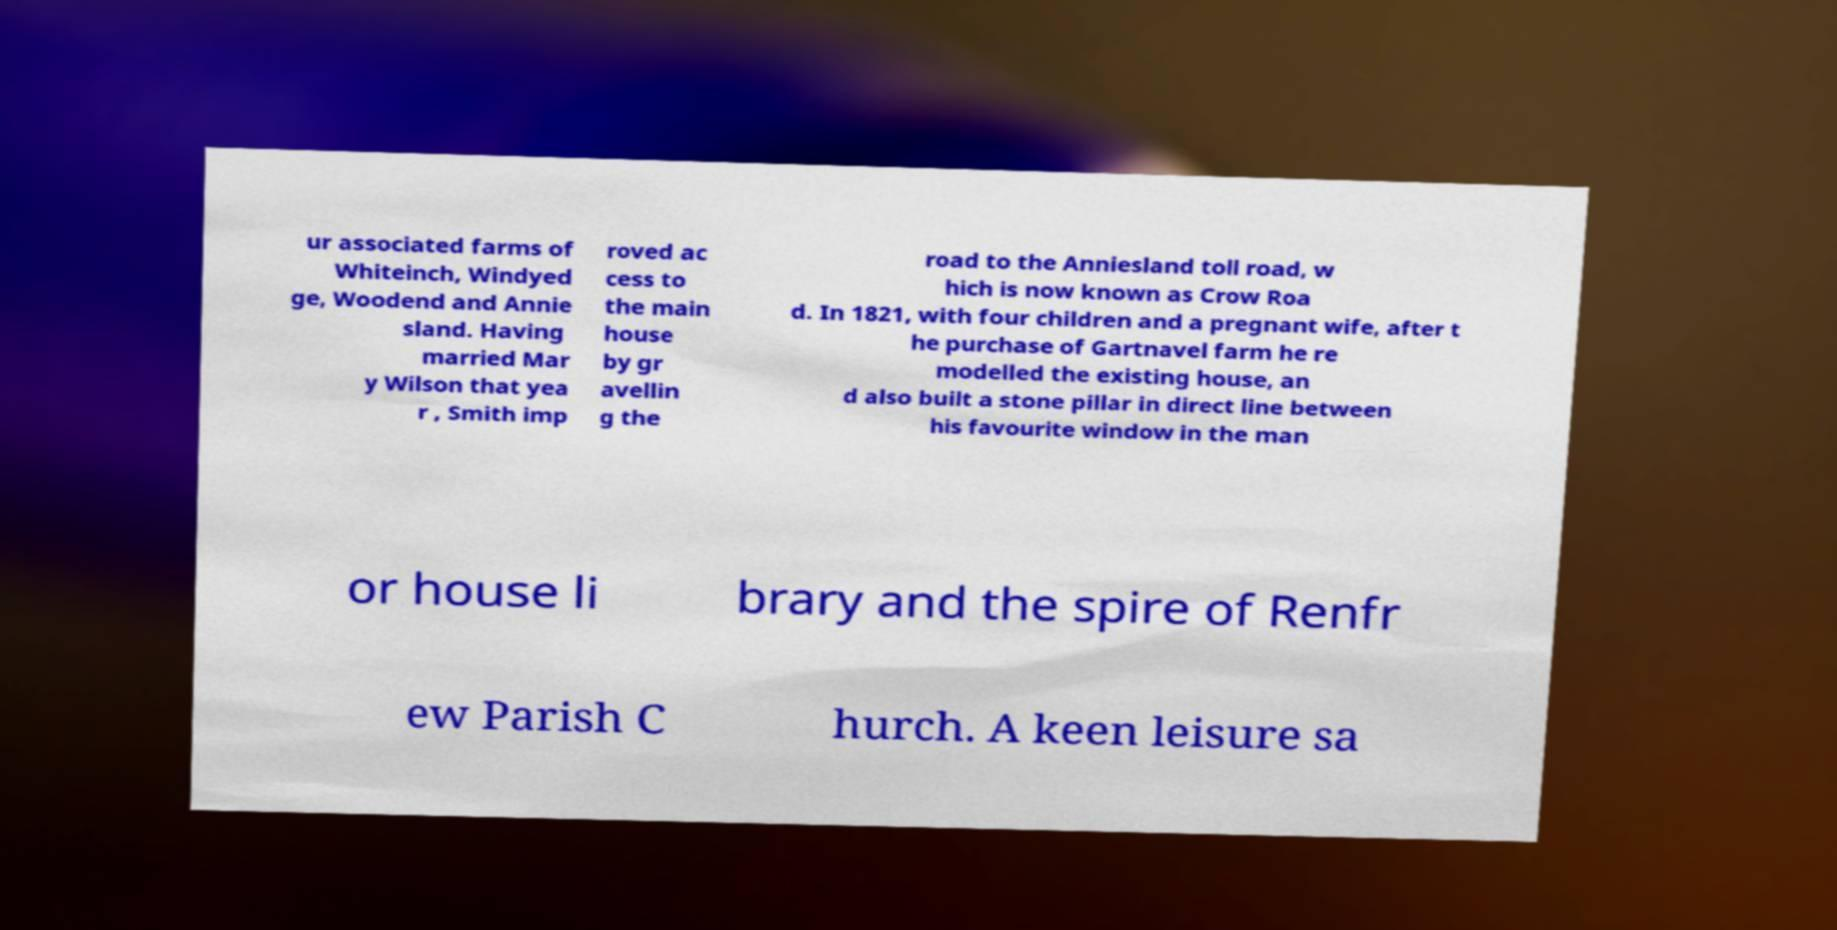What messages or text are displayed in this image? I need them in a readable, typed format. ur associated farms of Whiteinch, Windyed ge, Woodend and Annie sland. Having married Mar y Wilson that yea r , Smith imp roved ac cess to the main house by gr avellin g the road to the Anniesland toll road, w hich is now known as Crow Roa d. In 1821, with four children and a pregnant wife, after t he purchase of Gartnavel farm he re modelled the existing house, an d also built a stone pillar in direct line between his favourite window in the man or house li brary and the spire of Renfr ew Parish C hurch. A keen leisure sa 